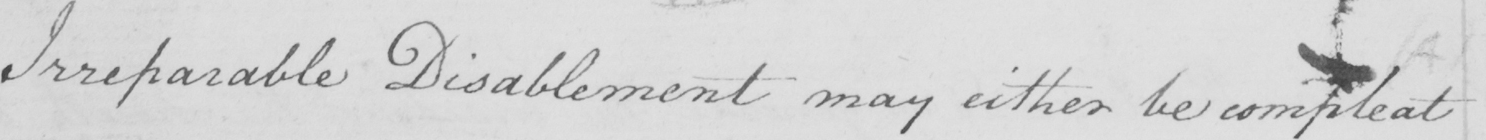Please provide the text content of this handwritten line. Irreparable Disablement may either be compleat 